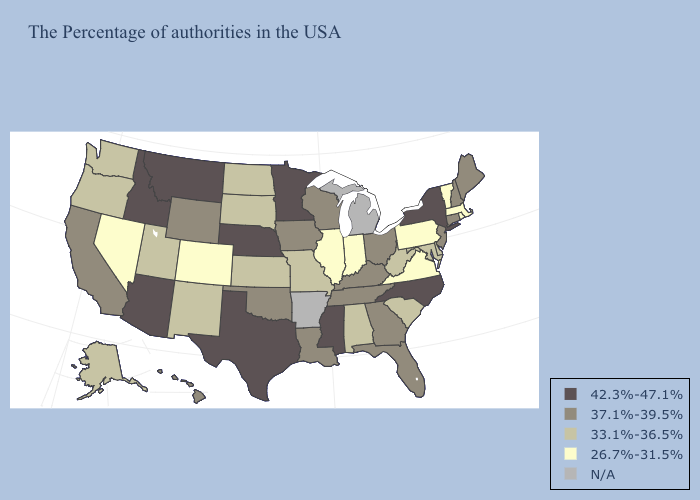Name the states that have a value in the range 42.3%-47.1%?
Short answer required. New York, North Carolina, Mississippi, Minnesota, Nebraska, Texas, Montana, Arizona, Idaho. Name the states that have a value in the range 42.3%-47.1%?
Answer briefly. New York, North Carolina, Mississippi, Minnesota, Nebraska, Texas, Montana, Arizona, Idaho. Name the states that have a value in the range N/A?
Be succinct. Michigan, Arkansas. Name the states that have a value in the range 33.1%-36.5%?
Quick response, please. Delaware, Maryland, South Carolina, West Virginia, Alabama, Missouri, Kansas, South Dakota, North Dakota, New Mexico, Utah, Washington, Oregon, Alaska. How many symbols are there in the legend?
Answer briefly. 5. Name the states that have a value in the range 26.7%-31.5%?
Concise answer only. Massachusetts, Rhode Island, Vermont, Pennsylvania, Virginia, Indiana, Illinois, Colorado, Nevada. Name the states that have a value in the range 37.1%-39.5%?
Short answer required. Maine, New Hampshire, Connecticut, New Jersey, Ohio, Florida, Georgia, Kentucky, Tennessee, Wisconsin, Louisiana, Iowa, Oklahoma, Wyoming, California, Hawaii. What is the value of South Carolina?
Quick response, please. 33.1%-36.5%. Which states hav the highest value in the MidWest?
Concise answer only. Minnesota, Nebraska. Name the states that have a value in the range 26.7%-31.5%?
Keep it brief. Massachusetts, Rhode Island, Vermont, Pennsylvania, Virginia, Indiana, Illinois, Colorado, Nevada. What is the value of Massachusetts?
Short answer required. 26.7%-31.5%. How many symbols are there in the legend?
Answer briefly. 5. Name the states that have a value in the range 33.1%-36.5%?
Short answer required. Delaware, Maryland, South Carolina, West Virginia, Alabama, Missouri, Kansas, South Dakota, North Dakota, New Mexico, Utah, Washington, Oregon, Alaska. 